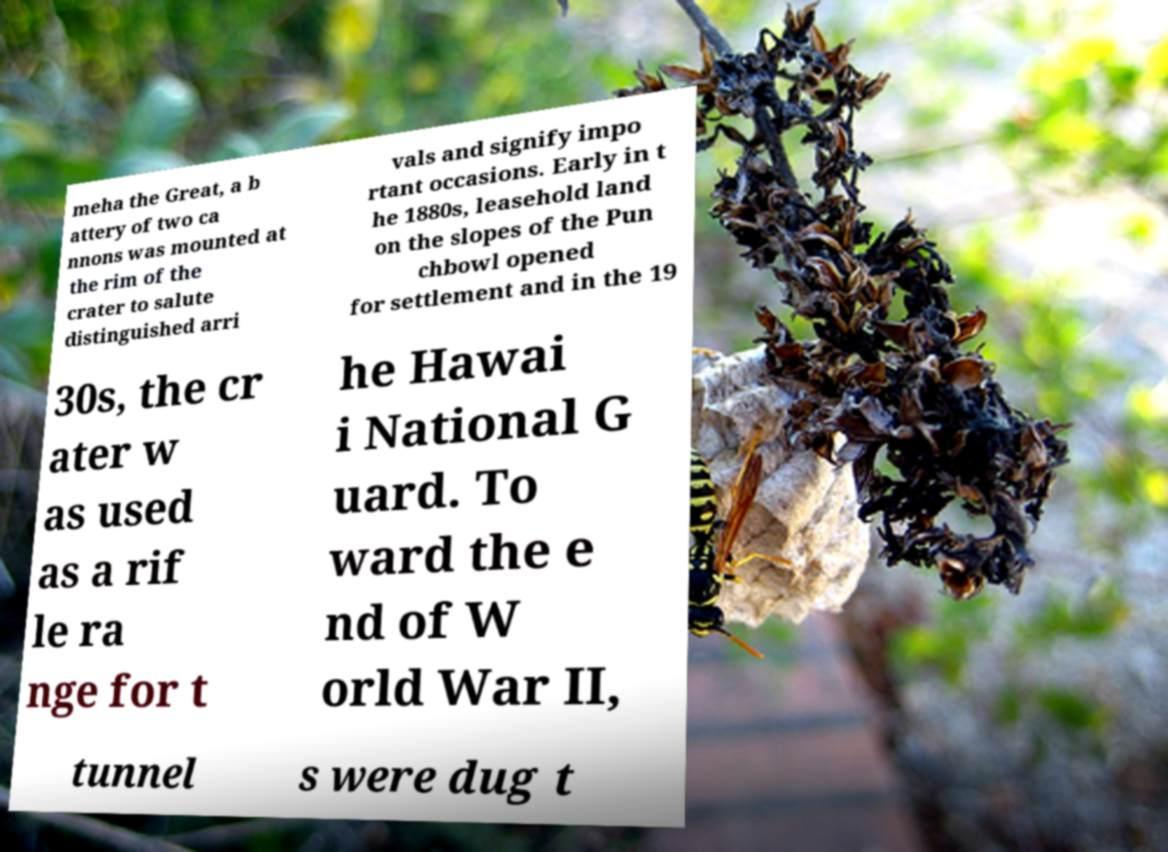What messages or text are displayed in this image? I need them in a readable, typed format. meha the Great, a b attery of two ca nnons was mounted at the rim of the crater to salute distinguished arri vals and signify impo rtant occasions. Early in t he 1880s, leasehold land on the slopes of the Pun chbowl opened for settlement and in the 19 30s, the cr ater w as used as a rif le ra nge for t he Hawai i National G uard. To ward the e nd of W orld War II, tunnel s were dug t 